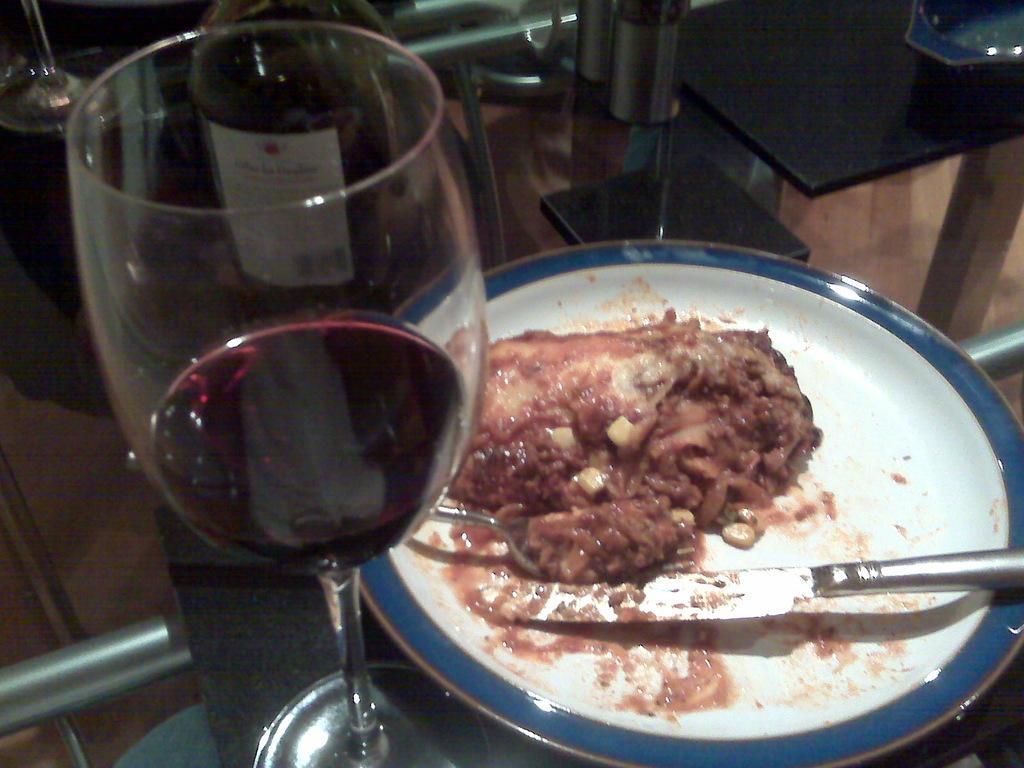Describe this image in one or two sentences. In this image I can see a wine glass, a plate with the food, a fork and a knife. I can see another glass and other objects kept on a glass table. 